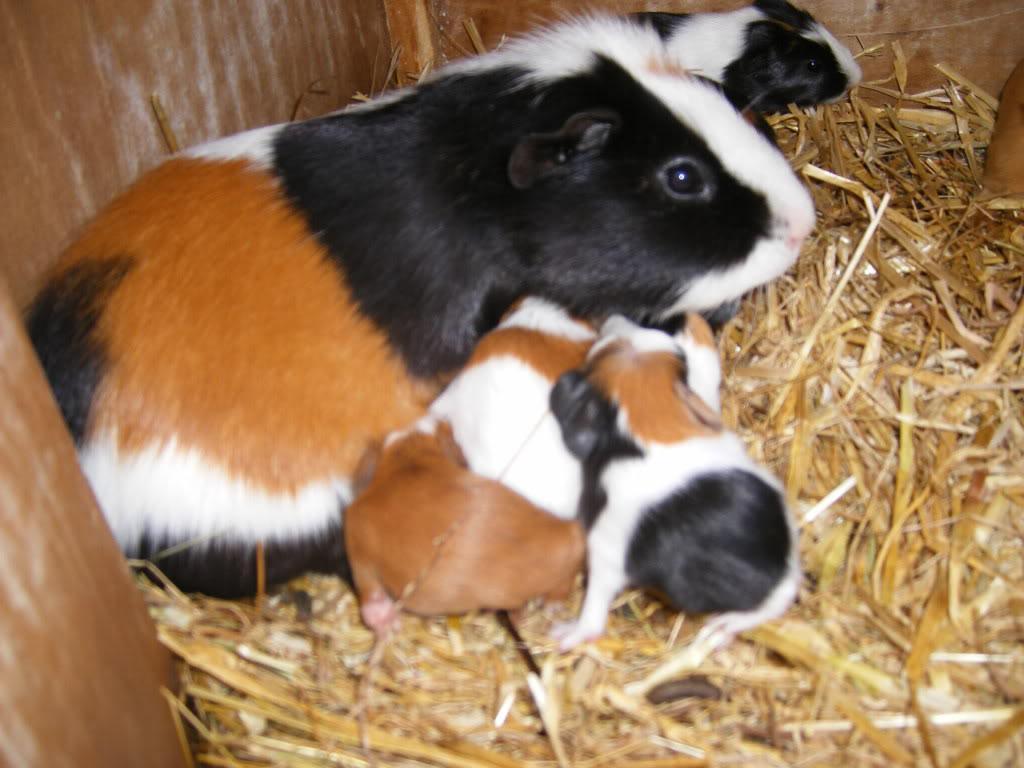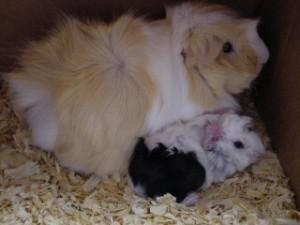The first image is the image on the left, the second image is the image on the right. Evaluate the accuracy of this statement regarding the images: "there are guinea pigs on straw hay in a wooden pen". Is it true? Answer yes or no. Yes. The first image is the image on the left, the second image is the image on the right. Evaluate the accuracy of this statement regarding the images: "At least one guinea pig is looking straight ahead.". Is it true? Answer yes or no. No. 